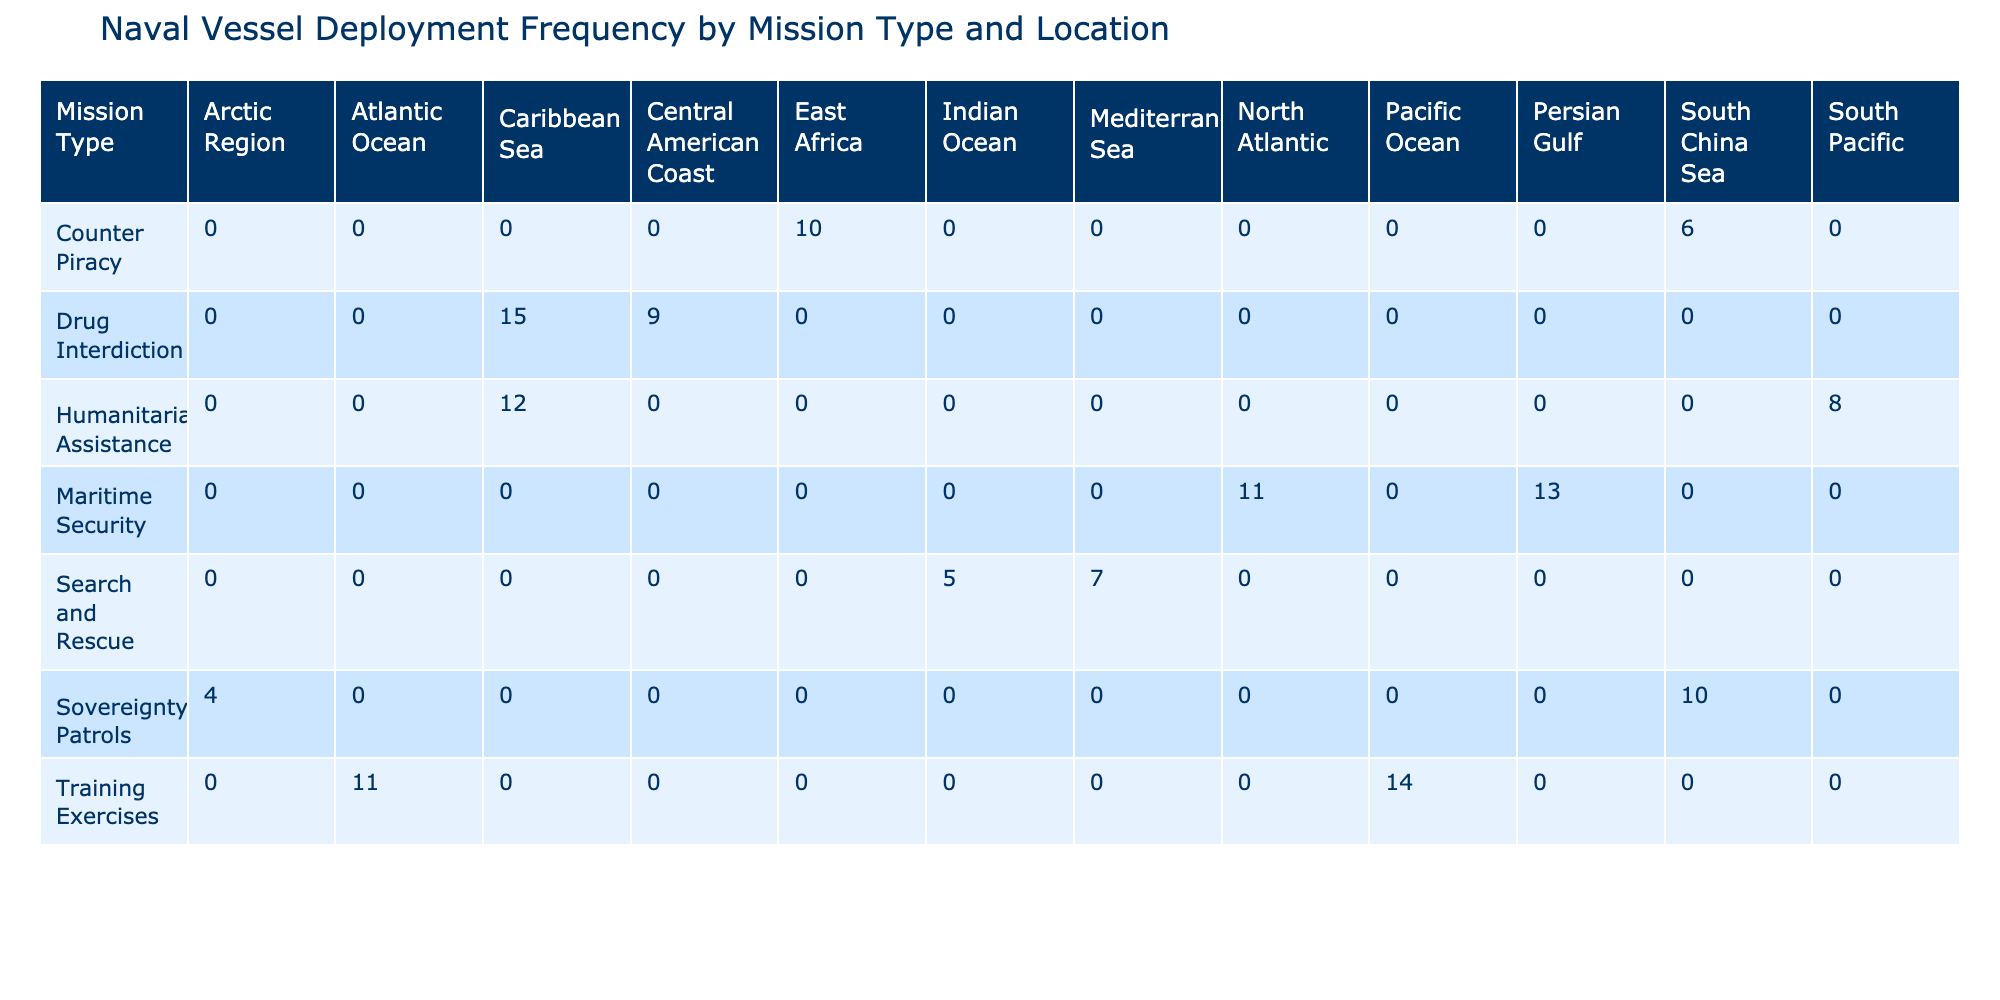What is the deployment frequency for Drug Interdiction in the Caribbean Sea? The table indicates that under the mission type Drug Interdiction in the Caribbean Sea, the deployment frequency is listed as 15.
Answer: 15 What is the total deployment frequency for Maritime Security across all locations? In the table, the deployment frequencies for Maritime Security are as follows: North Atlantic (11) and Persian Gulf (13). Summing these gives: 11 + 13 = 24.
Answer: 24 Is there any mission type deployed in the South Pacific? Looking at the table, the only mission type in the South Pacific is Humanitarian Assistance which has a deployment frequency of 8. This confirms that there is a mission type deployed in that region.
Answer: Yes Which mission type has the highest deployment frequency overall? To find the mission type with the highest frequency, we sum the deployment frequencies for each mission type: Humanitarian Assistance (12 + 8 = 20), Counter Piracy (10 + 6 = 16), Drug Interdiction (15 + 9 = 24), Maritime Security (11 + 13 = 24), Search and Rescue (7 + 5 = 12), Sovereignty Patrols (4 + 10 = 14), and Training Exercises (14 + 11 = 25). The highest is Training Exercises with a total of 25.
Answer: Training Exercises What is the average deployment frequency for Search and Rescue missions? The table lists two deployment frequencies for Search and Rescue: Mediterranean Sea (7) and Indian Ocean (5). First, sum these values: 7 + 5 = 12. Then, to find the average, divide by the number of locations (2): 12 / 2 = 6.
Answer: 6 Which location has the lowest deployment frequency overall? Reviewing the table, we look for the lowest deployment frequency across all locations. The frequencies listed are: Caribbean Sea (15, 12), South Pacific (8), East Africa (10), South China Sea (6), Central American Coast (9), North Atlantic (11), Persian Gulf (13), Mediterranean Sea (7), Indian Ocean (5), Arctic Region (4), and Pacific Ocean (14). The lowest value is in the Arctic Region with a frequency of 4.
Answer: Arctic Region Is the deployment frequency for Sovereignty Patrols higher in the South China Sea compared to the Arctic Region? The table shows Sovereignty Patrols with a frequency of 10 in the South China Sea and 4 in the Arctic Region. Comparing these, 10 is greater than 4, which means the frequency is indeed higher in the South China Sea.
Answer: Yes What is the difference in deployment frequency between Training Exercises in the Pacific Ocean and Atlantic Ocean? Training Exercises have a frequency of 14 in the Pacific Ocean and 11 in the Atlantic Ocean. To find the difference, subtract the Atlantic frequency from the Pacific frequency: 14 - 11 = 3.
Answer: 3 Which mission type saw a higher deployment frequency in the Persian Gulf compared to East Africa? The deployment frequency for Maritime Security in the Persian Gulf is 13, while Counter Piracy in East Africa has a frequency of 10. Since 13 is greater than 10, this shows that the Persian Gulf has a higher frequency.
Answer: Yes 